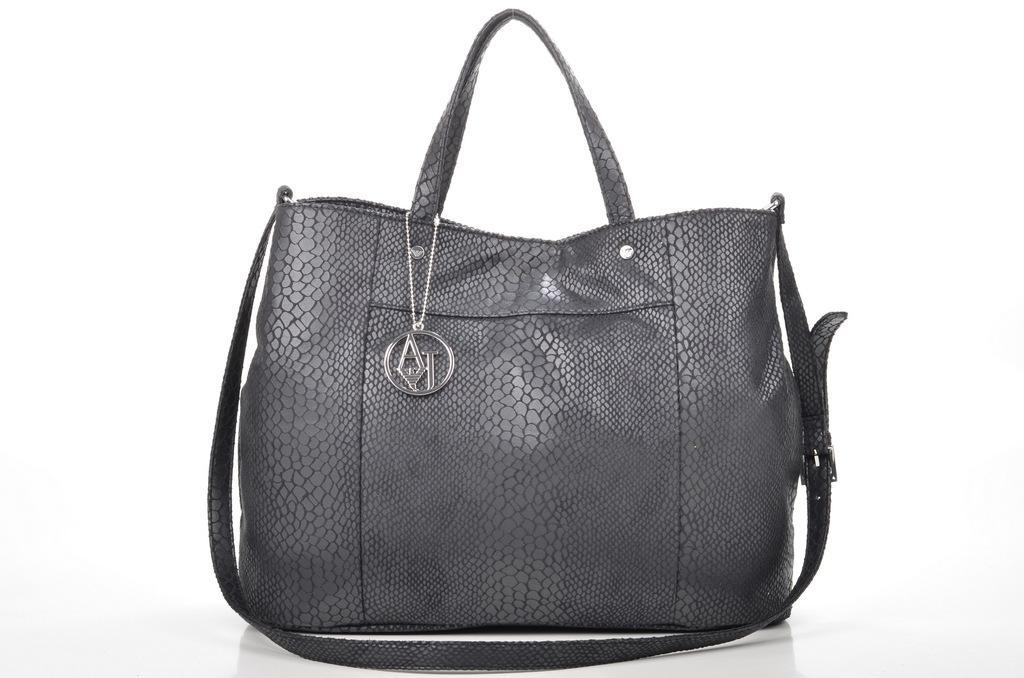Can you describe this image briefly? In the image we can see a handbag. This is a locket. 